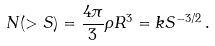<formula> <loc_0><loc_0><loc_500><loc_500>N ( > S ) = \frac { 4 \pi } { 3 } \rho R ^ { 3 } = k S ^ { - 3 / 2 } \, .</formula> 